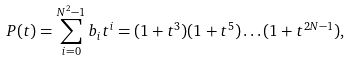<formula> <loc_0><loc_0><loc_500><loc_500>P ( t ) = \sum _ { i = 0 } ^ { N ^ { 2 } - 1 } b _ { i } t ^ { i } = ( 1 + t ^ { 3 } ) ( 1 + t ^ { 5 } ) \dots ( 1 + t ^ { 2 N - 1 } ) ,</formula> 